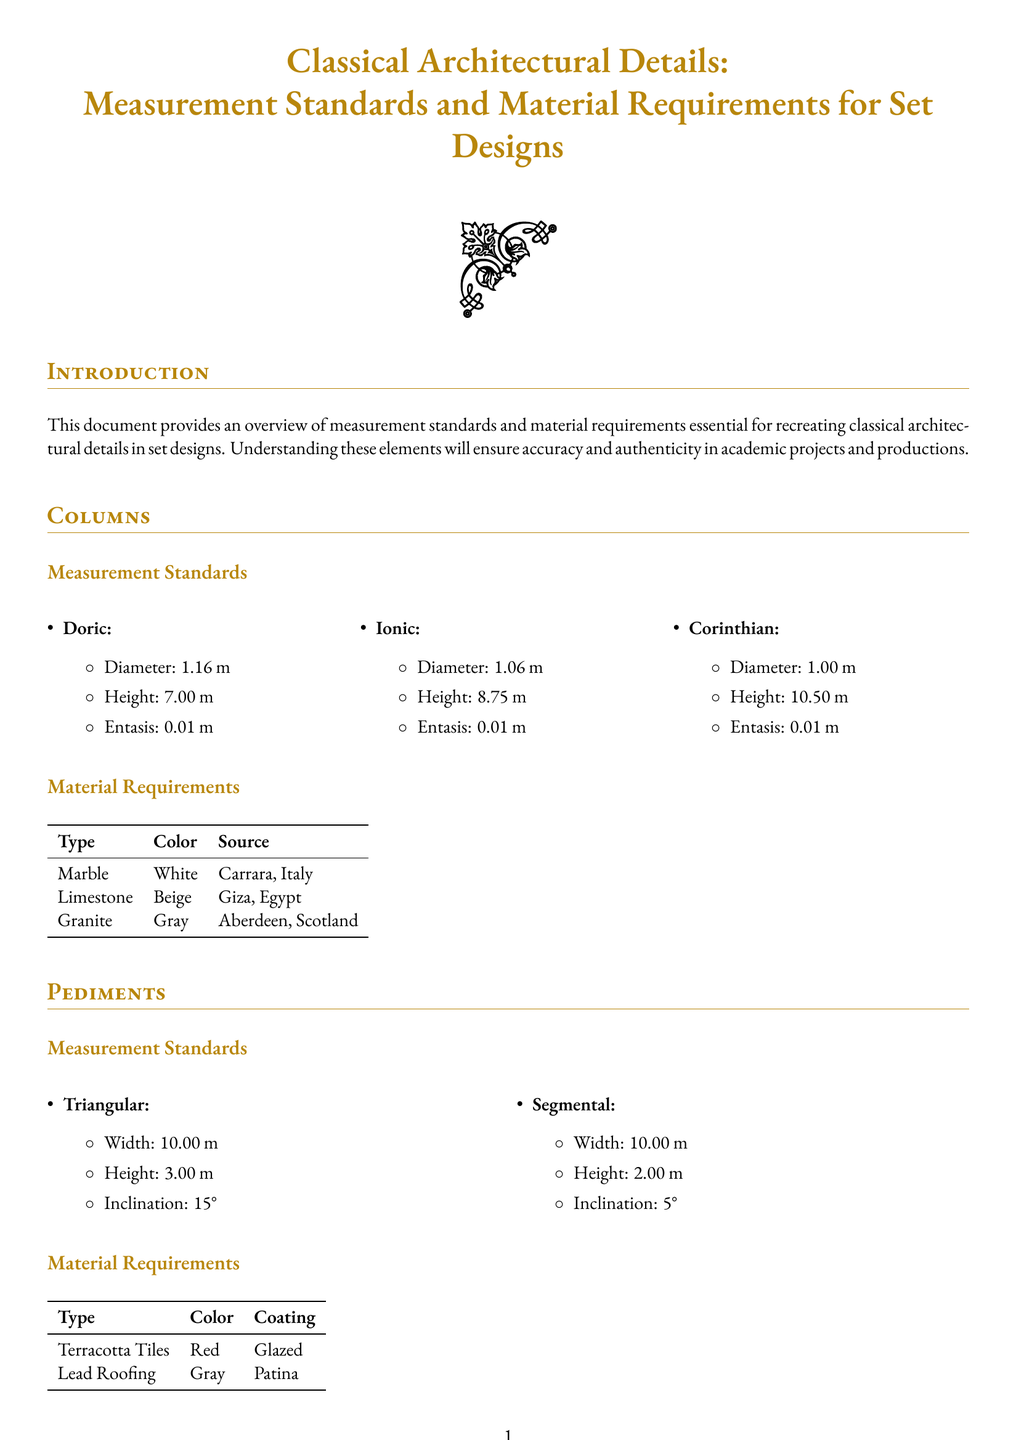What is the diameter of a Doric column? The diameter is specified under the Doric column section, which states it is 1.16 m.
Answer: 1.16 m What is the height of a Corinthian column? The height is listed in the Corinthian column section, which states it is 10.50 m.
Answer: 10.50 m What is the inclination of a triangular pediment? The inclination is specified in the section on triangular pediments, which states it is 15°.
Answer: 15° What type of coating is required for terracotta tiles? The material requirements section for pediments indicates that terracotta tiles should be glazed.
Answer: Glazed What is the color of the marble specified? Under material requirements for columns, it is indicated that marble is white.
Answer: White How many divisions are there in the entablature? The entablature section lists three divisions: Architrave, Frieze, and Cornice.
Answer: Three Which source is listed for gray granite? The material requirements specify that gray granite is sourced from Aberdeen, Scotland.
Answer: Aberdeen, Scotland Why is the entasis of the columns the same across all types? The document specifies a consistent entasis measurement for Doric, Ionic, and Corinthian columns, indicating standardization in design.
Answer: Standardization in design What is the material type for the cornice in the entablature? In the entablature section, it is stated that the cornice is made from wood.
Answer: Wood 